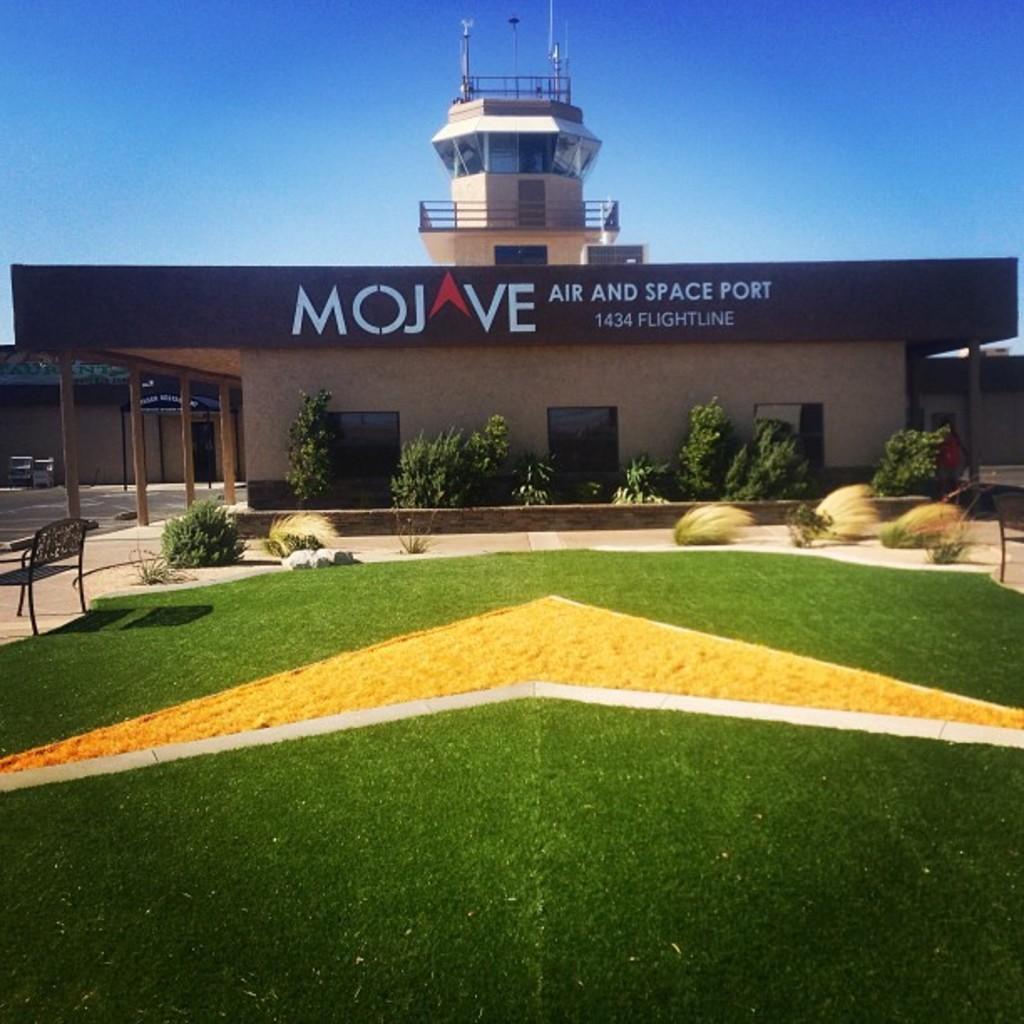In one or two sentences, can you explain what this image depicts? In this picture we can see grass, plants, chair, poles, houses, building, board and text on the wall. In the background of the image we can see the sky. 